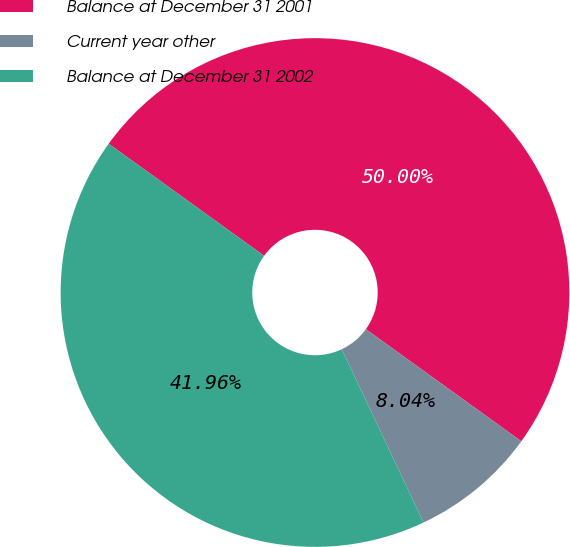Convert chart. <chart><loc_0><loc_0><loc_500><loc_500><pie_chart><fcel>Balance at December 31 2001<fcel>Current year other<fcel>Balance at December 31 2002<nl><fcel>50.0%<fcel>8.04%<fcel>41.96%<nl></chart> 